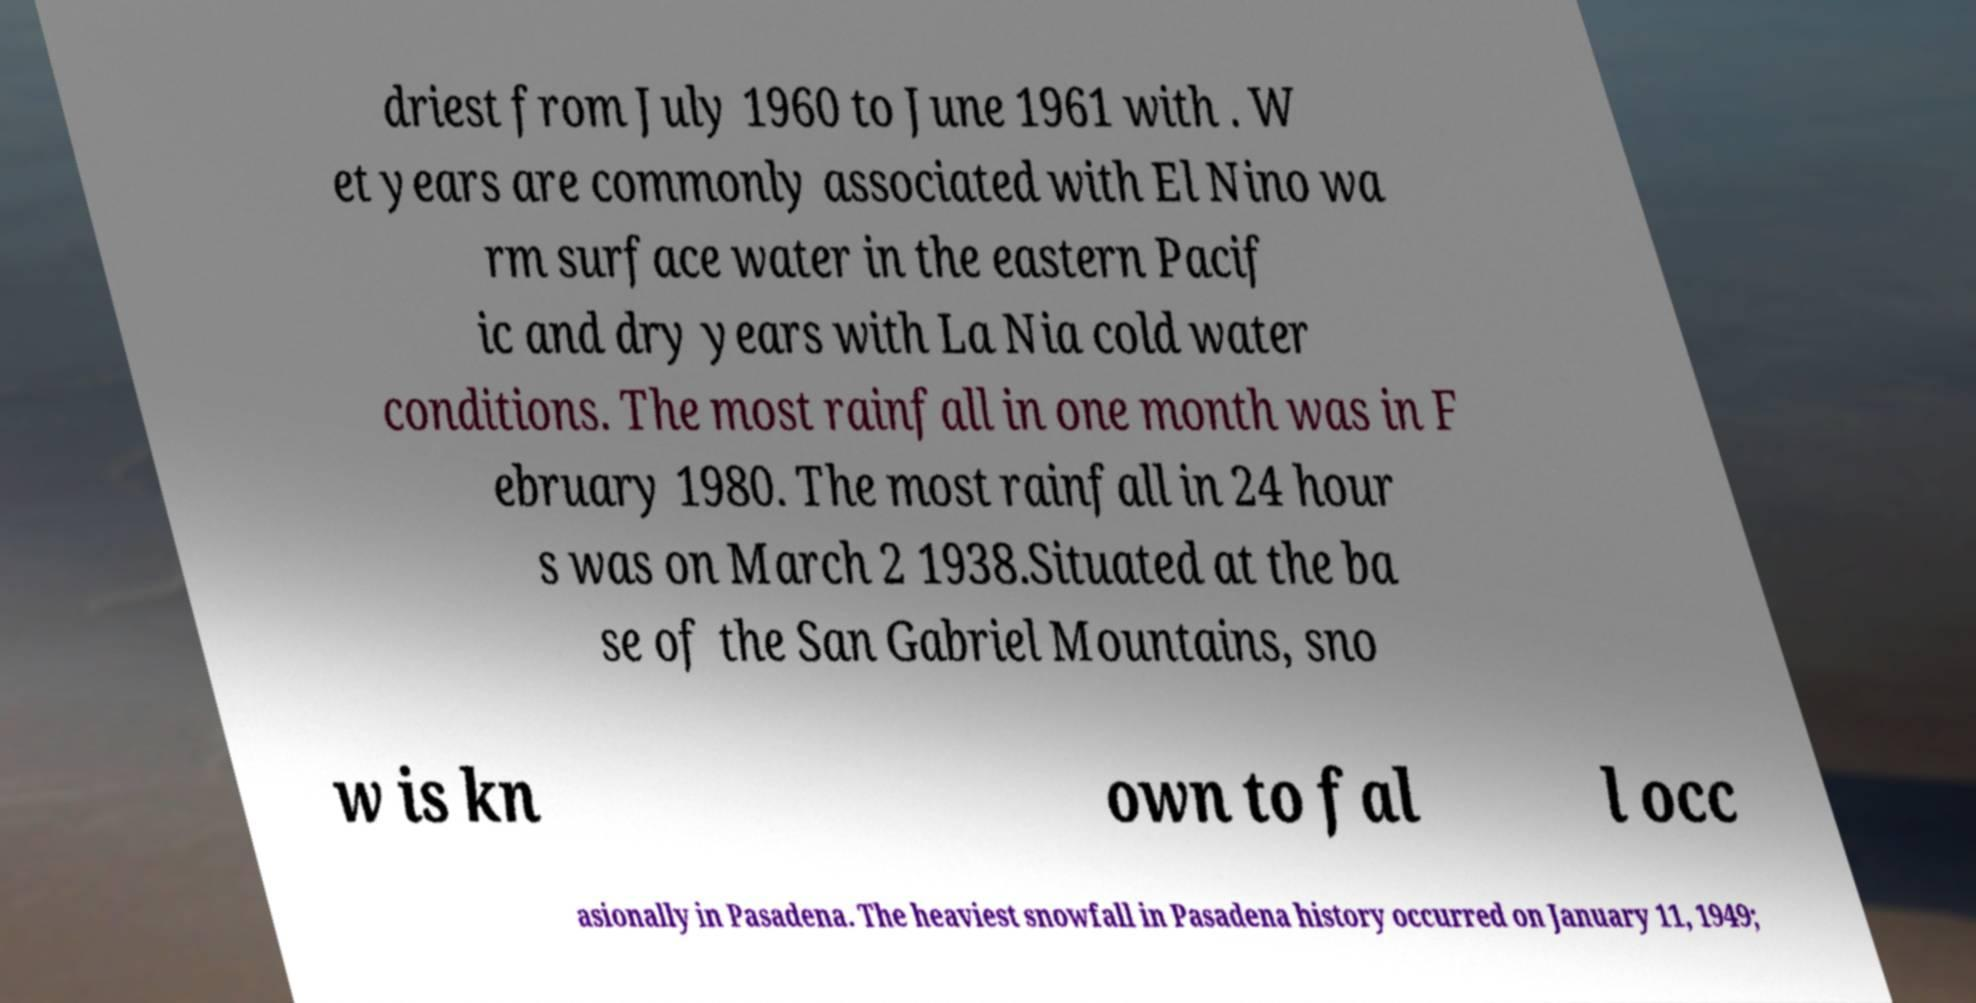Can you accurately transcribe the text from the provided image for me? driest from July 1960 to June 1961 with . W et years are commonly associated with El Nino wa rm surface water in the eastern Pacif ic and dry years with La Nia cold water conditions. The most rainfall in one month was in F ebruary 1980. The most rainfall in 24 hour s was on March 2 1938.Situated at the ba se of the San Gabriel Mountains, sno w is kn own to fal l occ asionally in Pasadena. The heaviest snowfall in Pasadena history occurred on January 11, 1949; 